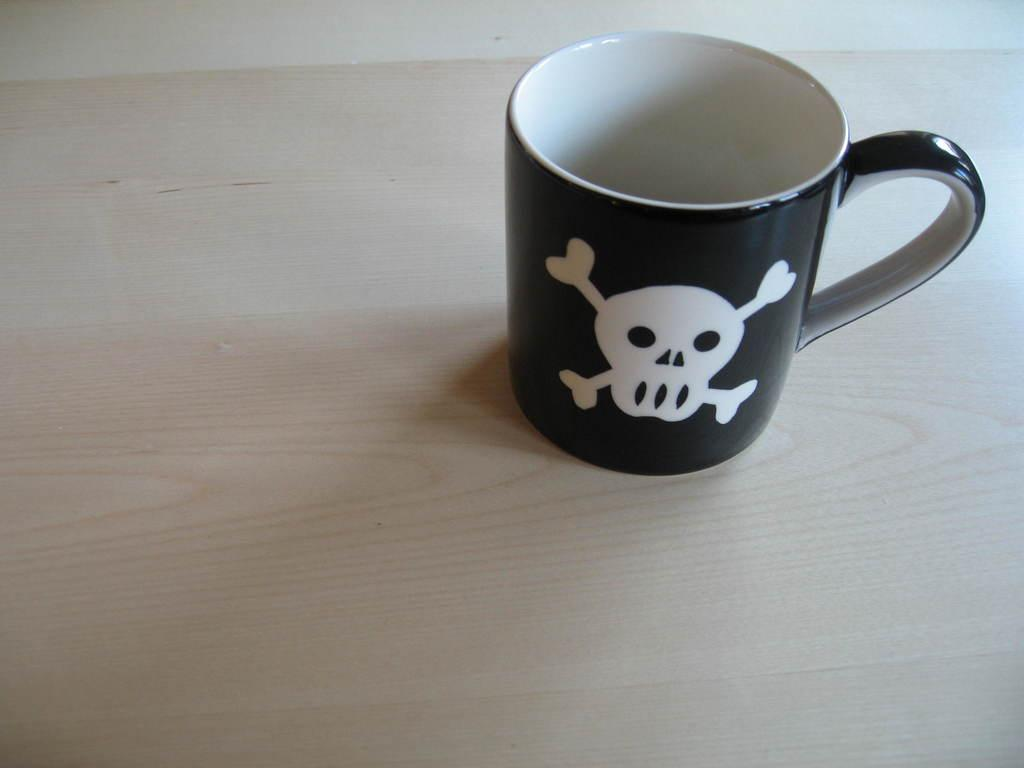What object is present in the image? There is a cup in the image. What is depicted on the cup? There is a painting on the cup. What type of crown can be seen on the cup in the image? There is no crown present on the cup in the image. What sound does the cup make when it is tapped in the image? The image does not depict any sounds or actions involving the cup, so it cannot be determined. 